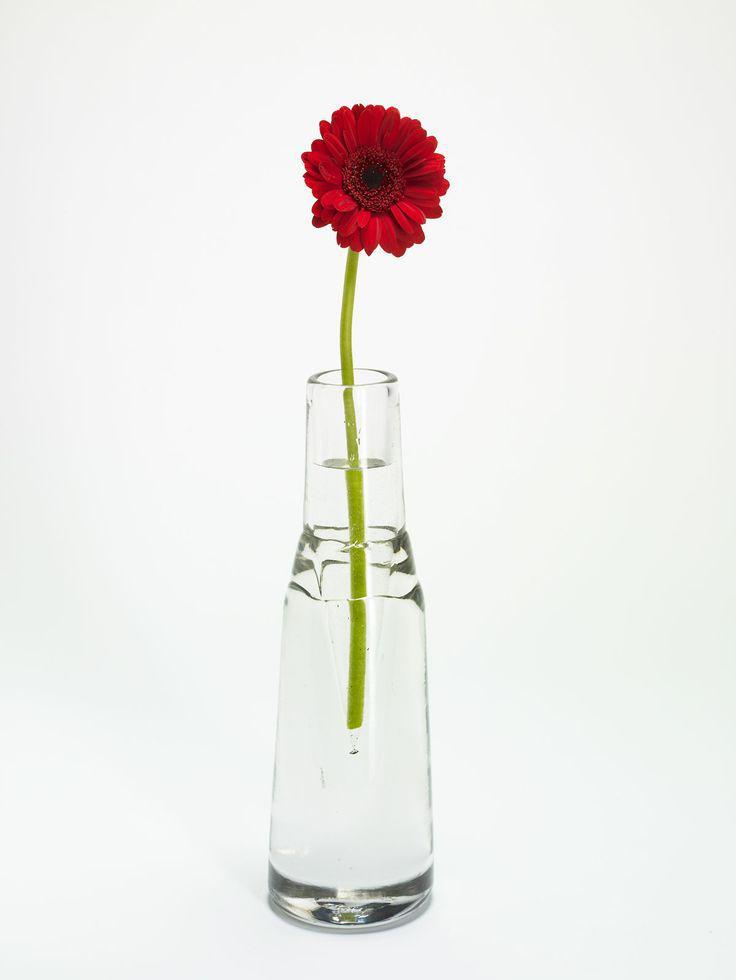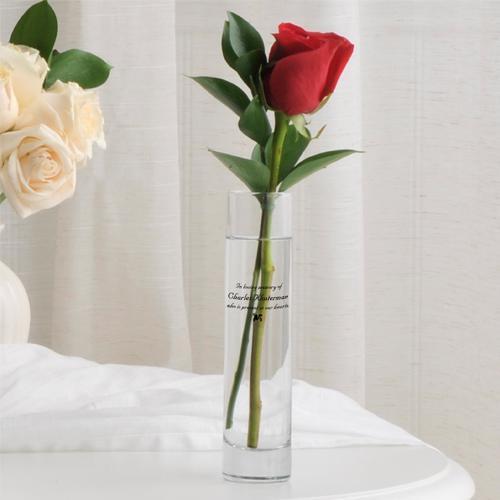The first image is the image on the left, the second image is the image on the right. Given the left and right images, does the statement "There are exactly two clear glass vases." hold true? Answer yes or no. Yes. The first image is the image on the left, the second image is the image on the right. Evaluate the accuracy of this statement regarding the images: "There are 2 vases.". Is it true? Answer yes or no. Yes. 